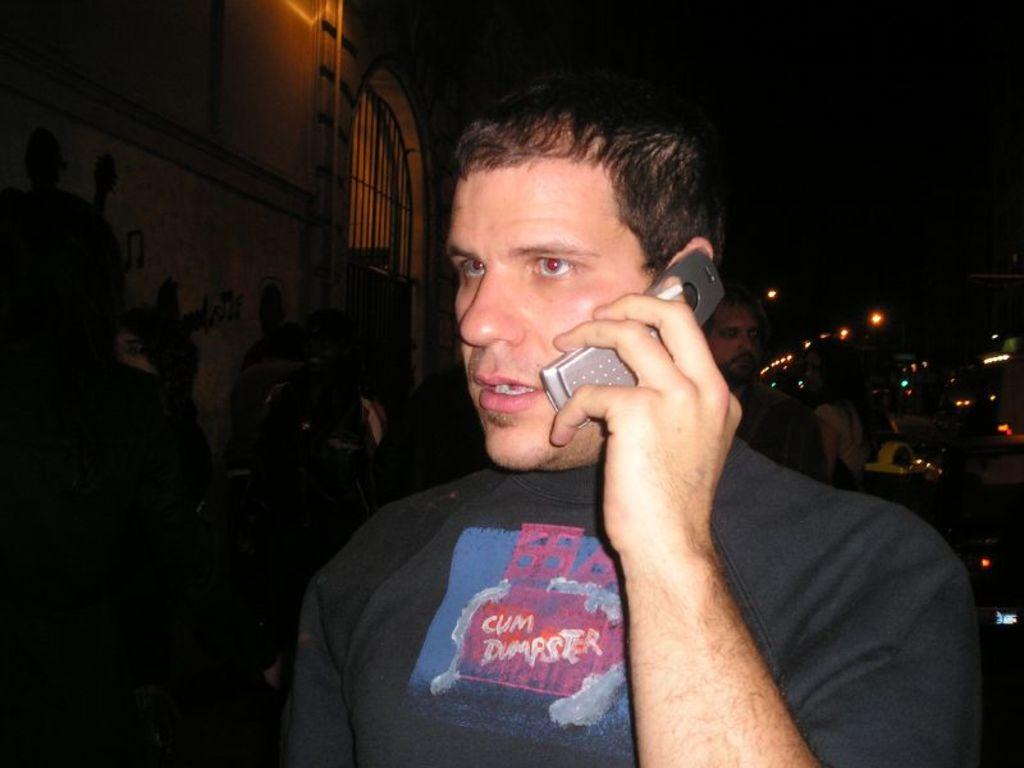Who or what can be seen in the image? There are people in the image. Where are the people located in relation to the building? The people are standing beside a building. What are the people doing in the image? The people are talking. What type of chess pieces can be seen on the table in the image? There is no table or chess pieces present in the image; it features people standing beside a building and talking. 